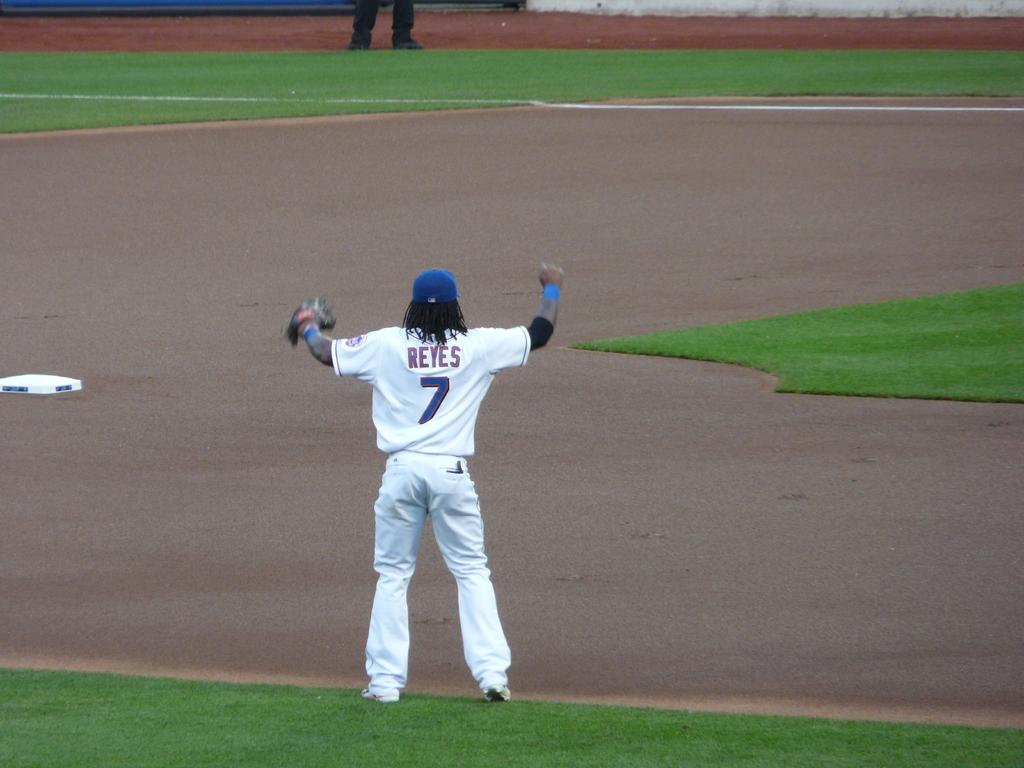<image>
Describe the image concisely. A baseball catcher has his arms outstretched for the ball and his uniform says Reyes 7. 